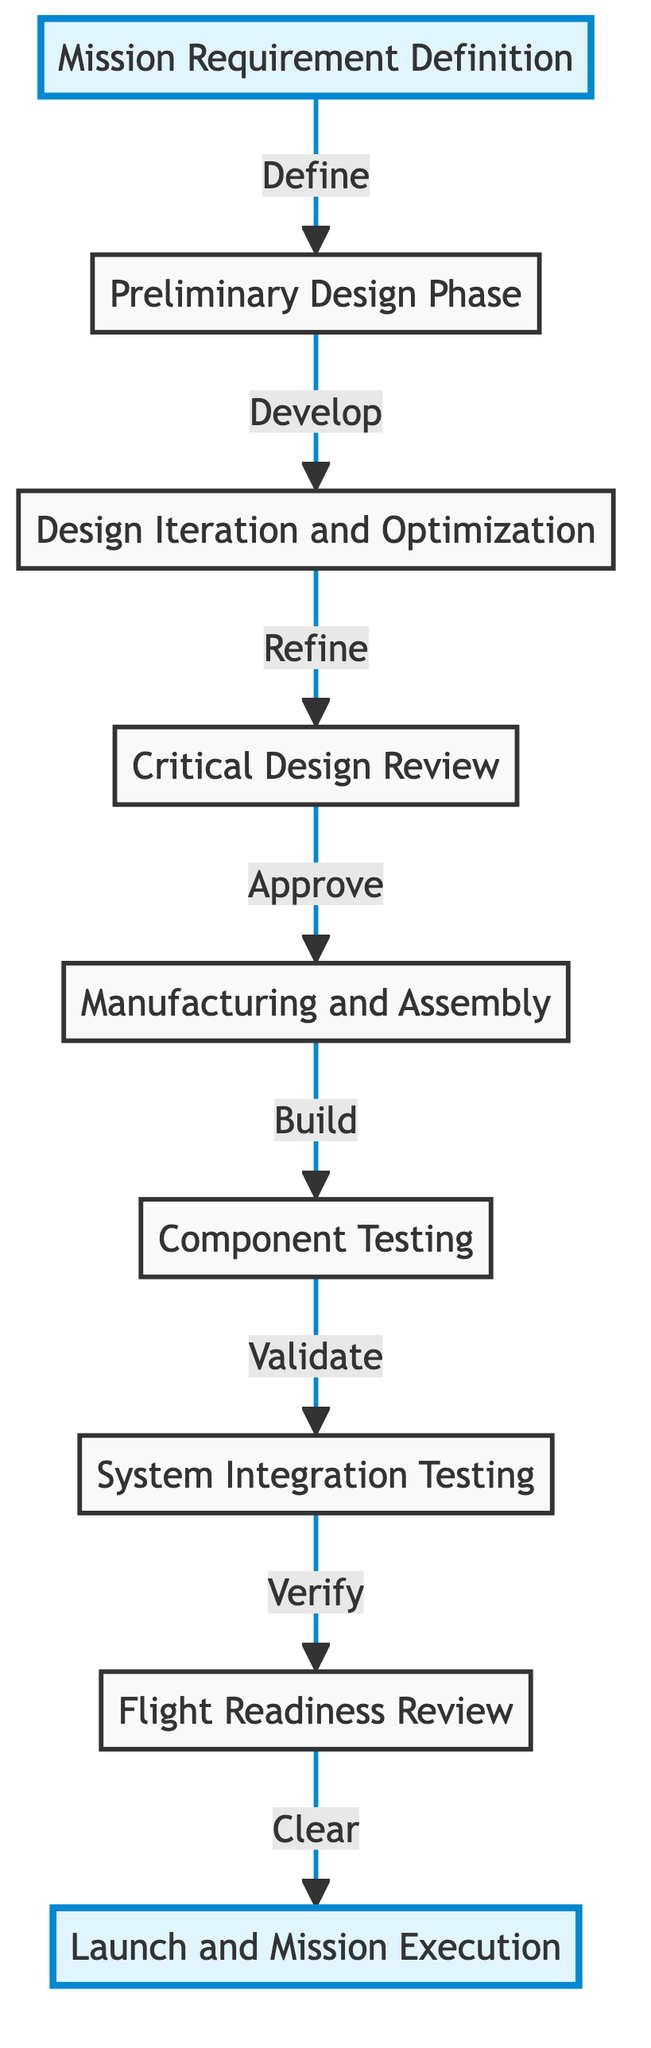What is the first step in the rocket propulsion system design process? The first step in the diagram is "Mission Requirement Definition," which is indicated as the starting point of the flowchart.
Answer: Mission Requirement Definition How many main phases are present in the design process? There are eight main phases listed in the diagram from "Mission Requirement Definition" to "Launch and Mission Execution."
Answer: Eight What is the relationship between the "Design Iteration and Optimization" and the "Critical Design Review"? The diagram shows that "Design Iteration and Optimization" leads to the "Critical Design Review" with the action "Refine," indicating a sequential relationship where refinement is reviewed critically.
Answer: Refine What step follows "Component Testing"? According to the diagram, the step that follows "Component Testing" is "System Integration Testing," as indicated by the directional arrow that connects these two nodes.
Answer: System Integration Testing What is the last step in the process? The last step as shown in the diagram is "Launch and Mission Execution," which is indicated as the final phase after the readiness has been reviewed.
Answer: Launch and Mission Execution What phase includes performance validation of individual components? The phase that includes performance validation of individual components, as indicated in the diagram, is "Component Testing."
Answer: Component Testing During which phase is the design critically evaluated before production? The phase where the design is critically evaluated before production is called the "Critical Design Review," as stated in the flowchart.
Answer: Critical Design Review What is the action between "Manufacturing and Assembly" and "Component Testing"? The action between the two nodes is represented as "Build," indicating that the components are built before they are tested.
Answer: Build 